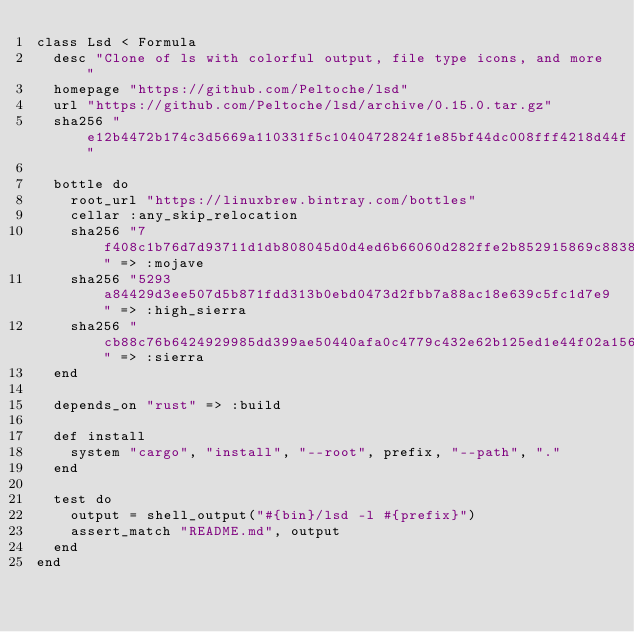<code> <loc_0><loc_0><loc_500><loc_500><_Ruby_>class Lsd < Formula
  desc "Clone of ls with colorful output, file type icons, and more"
  homepage "https://github.com/Peltoche/lsd"
  url "https://github.com/Peltoche/lsd/archive/0.15.0.tar.gz"
  sha256 "e12b4472b174c3d5669a110331f5c1040472824f1e85bf44dc008fff4218d44f"

  bottle do
    root_url "https://linuxbrew.bintray.com/bottles"
    cellar :any_skip_relocation
    sha256 "7f408c1b76d7d93711d1db808045d0d4ed6b66060d282ffe2b852915869c8838" => :mojave
    sha256 "5293a84429d3ee507d5b871fdd313b0ebd0473d2fbb7a88ac18e639c5fc1d7e9" => :high_sierra
    sha256 "cb88c76b6424929985dd399ae50440afa0c4779c432e62b125ed1e44f02a1561" => :sierra
  end

  depends_on "rust" => :build

  def install
    system "cargo", "install", "--root", prefix, "--path", "."
  end

  test do
    output = shell_output("#{bin}/lsd -l #{prefix}")
    assert_match "README.md", output
  end
end
</code> 